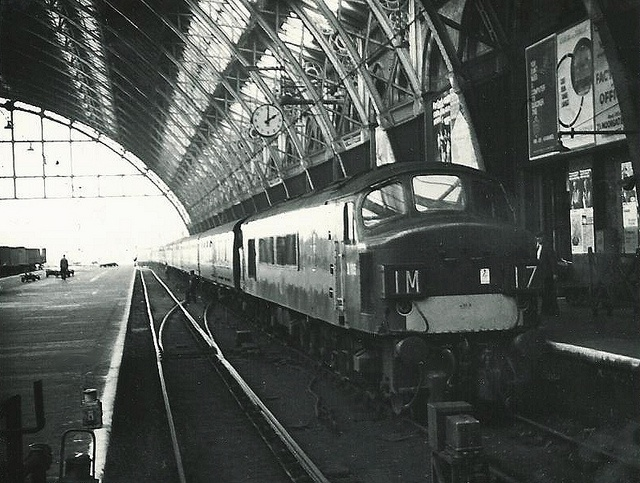Describe the objects in this image and their specific colors. I can see train in black, gray, ivory, and darkgray tones, clock in black, lightgray, darkgray, and gray tones, people in black, gray, and darkgray tones, and people in black, gray, and darkgray tones in this image. 